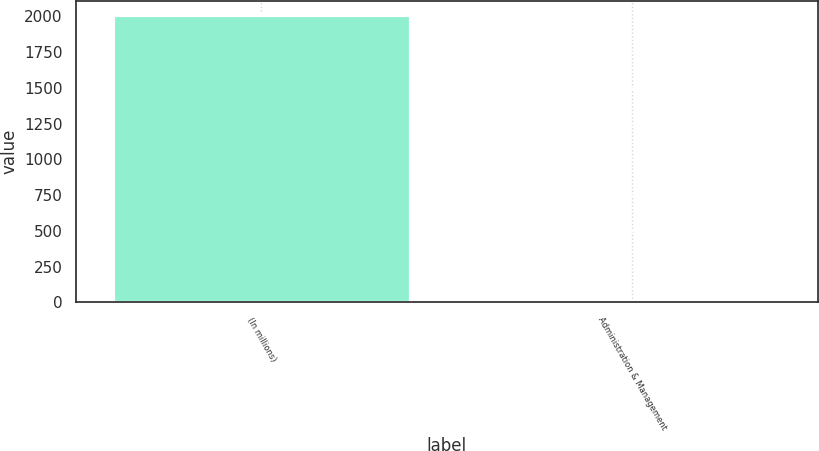Convert chart. <chart><loc_0><loc_0><loc_500><loc_500><bar_chart><fcel>(In millions)<fcel>Administration & Management<nl><fcel>2008<fcel>1.6<nl></chart> 